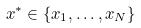<formula> <loc_0><loc_0><loc_500><loc_500>x ^ { * } \in \{ x _ { 1 } , \dots , x _ { N } \}</formula> 